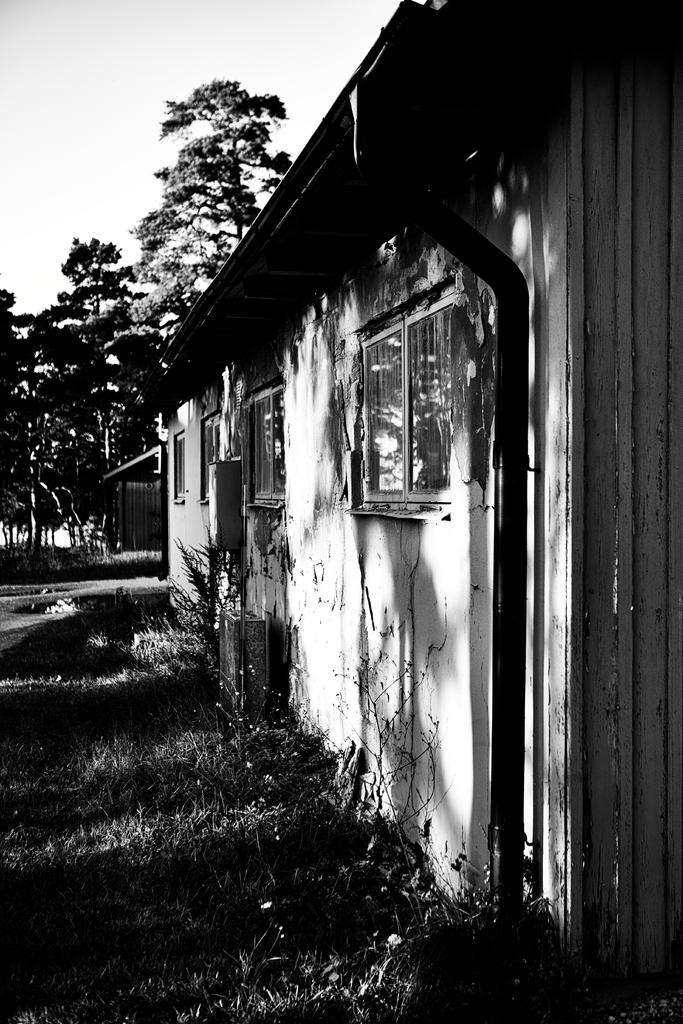What is the color scheme of the image? The image is black and white. What structure can be seen in the image? There is a house in the image. What features can be observed on the house? The house has windows. What type of vegetation is present on the left side of the house? There are plants and grass on the left side of the house. What is located behind the house? There are trees behind the house. What part of the natural environment is visible in the image? The sky is visible in the image. What type of knowledge can be gained from the light rule in the image? There is no knowledge, light, or rule present in the image. The image only provides information about the house, plants, grass, trees, and the sky. 